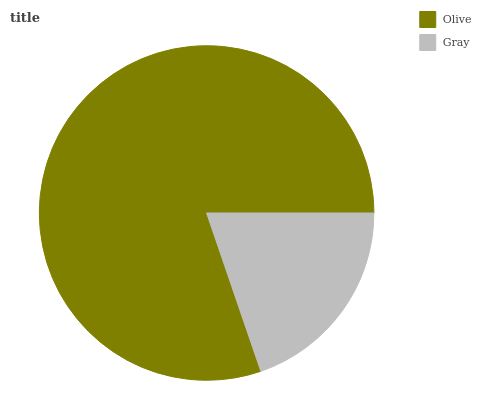Is Gray the minimum?
Answer yes or no. Yes. Is Olive the maximum?
Answer yes or no. Yes. Is Gray the maximum?
Answer yes or no. No. Is Olive greater than Gray?
Answer yes or no. Yes. Is Gray less than Olive?
Answer yes or no. Yes. Is Gray greater than Olive?
Answer yes or no. No. Is Olive less than Gray?
Answer yes or no. No. Is Olive the high median?
Answer yes or no. Yes. Is Gray the low median?
Answer yes or no. Yes. Is Gray the high median?
Answer yes or no. No. Is Olive the low median?
Answer yes or no. No. 